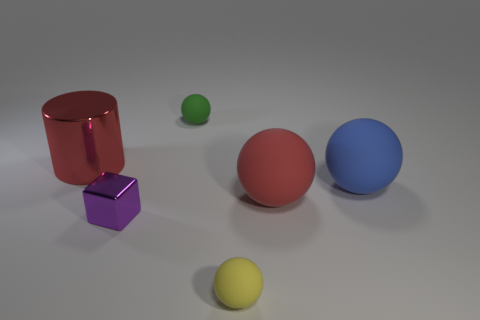Subtract all tiny green rubber balls. How many balls are left? 3 Subtract all purple spheres. Subtract all purple cylinders. How many spheres are left? 4 Add 2 small yellow things. How many objects exist? 8 Subtract all cylinders. How many objects are left? 5 Add 4 small yellow matte spheres. How many small yellow matte spheres are left? 5 Add 5 purple metal blocks. How many purple metal blocks exist? 6 Subtract 0 purple balls. How many objects are left? 6 Subtract all small cyan cubes. Subtract all shiny cylinders. How many objects are left? 5 